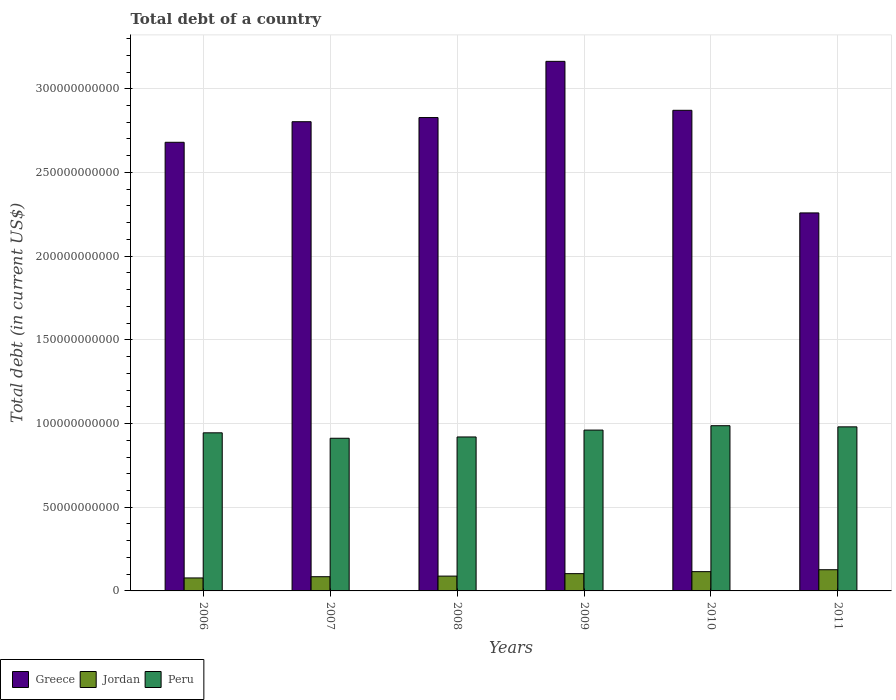How many groups of bars are there?
Your answer should be compact. 6. Are the number of bars per tick equal to the number of legend labels?
Offer a very short reply. Yes. How many bars are there on the 1st tick from the left?
Offer a very short reply. 3. How many bars are there on the 3rd tick from the right?
Make the answer very short. 3. In how many cases, is the number of bars for a given year not equal to the number of legend labels?
Your answer should be very brief. 0. What is the debt in Jordan in 2009?
Give a very brief answer. 1.03e+1. Across all years, what is the maximum debt in Peru?
Your answer should be compact. 9.87e+1. Across all years, what is the minimum debt in Jordan?
Give a very brief answer. 7.75e+09. In which year was the debt in Jordan minimum?
Keep it short and to the point. 2006. What is the total debt in Peru in the graph?
Provide a short and direct response. 5.70e+11. What is the difference between the debt in Greece in 2006 and that in 2009?
Provide a short and direct response. -4.84e+1. What is the difference between the debt in Jordan in 2010 and the debt in Peru in 2006?
Offer a very short reply. -8.29e+1. What is the average debt in Peru per year?
Keep it short and to the point. 9.51e+1. In the year 2007, what is the difference between the debt in Peru and debt in Jordan?
Give a very brief answer. 8.27e+1. In how many years, is the debt in Greece greater than 10000000000 US$?
Give a very brief answer. 6. What is the ratio of the debt in Jordan in 2007 to that in 2009?
Make the answer very short. 0.82. Is the difference between the debt in Peru in 2006 and 2011 greater than the difference between the debt in Jordan in 2006 and 2011?
Offer a very short reply. Yes. What is the difference between the highest and the second highest debt in Jordan?
Keep it short and to the point. 1.15e+09. What is the difference between the highest and the lowest debt in Peru?
Your answer should be very brief. 7.50e+09. What does the 2nd bar from the right in 2006 represents?
Provide a succinct answer. Jordan. How many bars are there?
Your answer should be very brief. 18. Are all the bars in the graph horizontal?
Offer a terse response. No. What is the difference between two consecutive major ticks on the Y-axis?
Your answer should be very brief. 5.00e+1. Are the values on the major ticks of Y-axis written in scientific E-notation?
Offer a terse response. No. Does the graph contain any zero values?
Offer a very short reply. No. Does the graph contain grids?
Give a very brief answer. Yes. How many legend labels are there?
Offer a very short reply. 3. How are the legend labels stacked?
Ensure brevity in your answer.  Horizontal. What is the title of the graph?
Offer a terse response. Total debt of a country. Does "Middle East & North Africa (developing only)" appear as one of the legend labels in the graph?
Your answer should be compact. No. What is the label or title of the Y-axis?
Keep it short and to the point. Total debt (in current US$). What is the Total debt (in current US$) in Greece in 2006?
Provide a succinct answer. 2.68e+11. What is the Total debt (in current US$) in Jordan in 2006?
Offer a terse response. 7.75e+09. What is the Total debt (in current US$) in Peru in 2006?
Ensure brevity in your answer.  9.45e+1. What is the Total debt (in current US$) of Greece in 2007?
Provide a succinct answer. 2.80e+11. What is the Total debt (in current US$) in Jordan in 2007?
Offer a terse response. 8.49e+09. What is the Total debt (in current US$) of Peru in 2007?
Provide a succinct answer. 9.12e+1. What is the Total debt (in current US$) of Greece in 2008?
Provide a short and direct response. 2.83e+11. What is the Total debt (in current US$) of Jordan in 2008?
Make the answer very short. 8.85e+09. What is the Total debt (in current US$) of Peru in 2008?
Ensure brevity in your answer.  9.20e+1. What is the Total debt (in current US$) of Greece in 2009?
Offer a terse response. 3.16e+11. What is the Total debt (in current US$) of Jordan in 2009?
Ensure brevity in your answer.  1.03e+1. What is the Total debt (in current US$) of Peru in 2009?
Your answer should be very brief. 9.61e+1. What is the Total debt (in current US$) of Greece in 2010?
Provide a succinct answer. 2.87e+11. What is the Total debt (in current US$) in Jordan in 2010?
Keep it short and to the point. 1.15e+1. What is the Total debt (in current US$) in Peru in 2010?
Offer a very short reply. 9.87e+1. What is the Total debt (in current US$) in Greece in 2011?
Give a very brief answer. 2.26e+11. What is the Total debt (in current US$) in Jordan in 2011?
Ensure brevity in your answer.  1.27e+1. What is the Total debt (in current US$) in Peru in 2011?
Offer a terse response. 9.80e+1. Across all years, what is the maximum Total debt (in current US$) in Greece?
Keep it short and to the point. 3.16e+11. Across all years, what is the maximum Total debt (in current US$) of Jordan?
Your answer should be very brief. 1.27e+1. Across all years, what is the maximum Total debt (in current US$) in Peru?
Make the answer very short. 9.87e+1. Across all years, what is the minimum Total debt (in current US$) in Greece?
Your answer should be compact. 2.26e+11. Across all years, what is the minimum Total debt (in current US$) of Jordan?
Offer a terse response. 7.75e+09. Across all years, what is the minimum Total debt (in current US$) in Peru?
Give a very brief answer. 9.12e+1. What is the total Total debt (in current US$) of Greece in the graph?
Give a very brief answer. 1.66e+12. What is the total Total debt (in current US$) of Jordan in the graph?
Your answer should be very brief. 5.96e+1. What is the total Total debt (in current US$) of Peru in the graph?
Your answer should be compact. 5.70e+11. What is the difference between the Total debt (in current US$) of Greece in 2006 and that in 2007?
Provide a succinct answer. -1.23e+1. What is the difference between the Total debt (in current US$) in Jordan in 2006 and that in 2007?
Ensure brevity in your answer.  -7.34e+08. What is the difference between the Total debt (in current US$) of Peru in 2006 and that in 2007?
Your answer should be very brief. 3.25e+09. What is the difference between the Total debt (in current US$) in Greece in 2006 and that in 2008?
Offer a terse response. -1.48e+1. What is the difference between the Total debt (in current US$) in Jordan in 2006 and that in 2008?
Make the answer very short. -1.10e+09. What is the difference between the Total debt (in current US$) of Peru in 2006 and that in 2008?
Offer a very short reply. 2.48e+09. What is the difference between the Total debt (in current US$) of Greece in 2006 and that in 2009?
Your answer should be very brief. -4.84e+1. What is the difference between the Total debt (in current US$) in Jordan in 2006 and that in 2009?
Your response must be concise. -2.56e+09. What is the difference between the Total debt (in current US$) in Peru in 2006 and that in 2009?
Give a very brief answer. -1.63e+09. What is the difference between the Total debt (in current US$) of Greece in 2006 and that in 2010?
Your answer should be compact. -1.91e+1. What is the difference between the Total debt (in current US$) of Jordan in 2006 and that in 2010?
Offer a terse response. -3.76e+09. What is the difference between the Total debt (in current US$) of Peru in 2006 and that in 2010?
Make the answer very short. -4.25e+09. What is the difference between the Total debt (in current US$) in Greece in 2006 and that in 2011?
Your response must be concise. 4.22e+1. What is the difference between the Total debt (in current US$) of Jordan in 2006 and that in 2011?
Your answer should be compact. -4.91e+09. What is the difference between the Total debt (in current US$) in Peru in 2006 and that in 2011?
Ensure brevity in your answer.  -3.56e+09. What is the difference between the Total debt (in current US$) of Greece in 2007 and that in 2008?
Keep it short and to the point. -2.48e+09. What is the difference between the Total debt (in current US$) of Jordan in 2007 and that in 2008?
Provide a succinct answer. -3.68e+08. What is the difference between the Total debt (in current US$) of Peru in 2007 and that in 2008?
Offer a very short reply. -7.72e+08. What is the difference between the Total debt (in current US$) of Greece in 2007 and that in 2009?
Your response must be concise. -3.61e+1. What is the difference between the Total debt (in current US$) in Jordan in 2007 and that in 2009?
Your answer should be very brief. -1.83e+09. What is the difference between the Total debt (in current US$) in Peru in 2007 and that in 2009?
Your answer should be compact. -4.88e+09. What is the difference between the Total debt (in current US$) in Greece in 2007 and that in 2010?
Provide a succinct answer. -6.82e+09. What is the difference between the Total debt (in current US$) in Jordan in 2007 and that in 2010?
Your answer should be compact. -3.03e+09. What is the difference between the Total debt (in current US$) in Peru in 2007 and that in 2010?
Your answer should be very brief. -7.50e+09. What is the difference between the Total debt (in current US$) of Greece in 2007 and that in 2011?
Your response must be concise. 5.45e+1. What is the difference between the Total debt (in current US$) in Jordan in 2007 and that in 2011?
Ensure brevity in your answer.  -4.18e+09. What is the difference between the Total debt (in current US$) in Peru in 2007 and that in 2011?
Make the answer very short. -6.81e+09. What is the difference between the Total debt (in current US$) in Greece in 2008 and that in 2009?
Your answer should be compact. -3.36e+1. What is the difference between the Total debt (in current US$) of Jordan in 2008 and that in 2009?
Provide a succinct answer. -1.46e+09. What is the difference between the Total debt (in current US$) of Peru in 2008 and that in 2009?
Your answer should be very brief. -4.11e+09. What is the difference between the Total debt (in current US$) of Greece in 2008 and that in 2010?
Your response must be concise. -4.34e+09. What is the difference between the Total debt (in current US$) in Jordan in 2008 and that in 2010?
Give a very brief answer. -2.66e+09. What is the difference between the Total debt (in current US$) in Peru in 2008 and that in 2010?
Provide a succinct answer. -6.73e+09. What is the difference between the Total debt (in current US$) in Greece in 2008 and that in 2011?
Ensure brevity in your answer.  5.70e+1. What is the difference between the Total debt (in current US$) of Jordan in 2008 and that in 2011?
Your answer should be compact. -3.81e+09. What is the difference between the Total debt (in current US$) of Peru in 2008 and that in 2011?
Give a very brief answer. -6.04e+09. What is the difference between the Total debt (in current US$) in Greece in 2009 and that in 2010?
Keep it short and to the point. 2.92e+1. What is the difference between the Total debt (in current US$) of Jordan in 2009 and that in 2010?
Your answer should be very brief. -1.20e+09. What is the difference between the Total debt (in current US$) of Peru in 2009 and that in 2010?
Your response must be concise. -2.62e+09. What is the difference between the Total debt (in current US$) in Greece in 2009 and that in 2011?
Your response must be concise. 9.05e+1. What is the difference between the Total debt (in current US$) of Jordan in 2009 and that in 2011?
Offer a terse response. -2.35e+09. What is the difference between the Total debt (in current US$) in Peru in 2009 and that in 2011?
Your answer should be compact. -1.93e+09. What is the difference between the Total debt (in current US$) of Greece in 2010 and that in 2011?
Offer a very short reply. 6.13e+1. What is the difference between the Total debt (in current US$) in Jordan in 2010 and that in 2011?
Provide a succinct answer. -1.15e+09. What is the difference between the Total debt (in current US$) in Peru in 2010 and that in 2011?
Make the answer very short. 6.85e+08. What is the difference between the Total debt (in current US$) in Greece in 2006 and the Total debt (in current US$) in Jordan in 2007?
Your answer should be very brief. 2.60e+11. What is the difference between the Total debt (in current US$) of Greece in 2006 and the Total debt (in current US$) of Peru in 2007?
Your answer should be very brief. 1.77e+11. What is the difference between the Total debt (in current US$) of Jordan in 2006 and the Total debt (in current US$) of Peru in 2007?
Make the answer very short. -8.35e+1. What is the difference between the Total debt (in current US$) in Greece in 2006 and the Total debt (in current US$) in Jordan in 2008?
Keep it short and to the point. 2.59e+11. What is the difference between the Total debt (in current US$) of Greece in 2006 and the Total debt (in current US$) of Peru in 2008?
Your answer should be compact. 1.76e+11. What is the difference between the Total debt (in current US$) in Jordan in 2006 and the Total debt (in current US$) in Peru in 2008?
Provide a succinct answer. -8.42e+1. What is the difference between the Total debt (in current US$) in Greece in 2006 and the Total debt (in current US$) in Jordan in 2009?
Provide a short and direct response. 2.58e+11. What is the difference between the Total debt (in current US$) of Greece in 2006 and the Total debt (in current US$) of Peru in 2009?
Provide a short and direct response. 1.72e+11. What is the difference between the Total debt (in current US$) in Jordan in 2006 and the Total debt (in current US$) in Peru in 2009?
Offer a terse response. -8.83e+1. What is the difference between the Total debt (in current US$) of Greece in 2006 and the Total debt (in current US$) of Jordan in 2010?
Offer a very short reply. 2.57e+11. What is the difference between the Total debt (in current US$) in Greece in 2006 and the Total debt (in current US$) in Peru in 2010?
Your response must be concise. 1.69e+11. What is the difference between the Total debt (in current US$) of Jordan in 2006 and the Total debt (in current US$) of Peru in 2010?
Your answer should be compact. -9.09e+1. What is the difference between the Total debt (in current US$) in Greece in 2006 and the Total debt (in current US$) in Jordan in 2011?
Your response must be concise. 2.55e+11. What is the difference between the Total debt (in current US$) of Greece in 2006 and the Total debt (in current US$) of Peru in 2011?
Keep it short and to the point. 1.70e+11. What is the difference between the Total debt (in current US$) in Jordan in 2006 and the Total debt (in current US$) in Peru in 2011?
Your answer should be compact. -9.03e+1. What is the difference between the Total debt (in current US$) of Greece in 2007 and the Total debt (in current US$) of Jordan in 2008?
Your response must be concise. 2.71e+11. What is the difference between the Total debt (in current US$) in Greece in 2007 and the Total debt (in current US$) in Peru in 2008?
Provide a succinct answer. 1.88e+11. What is the difference between the Total debt (in current US$) of Jordan in 2007 and the Total debt (in current US$) of Peru in 2008?
Your answer should be very brief. -8.35e+1. What is the difference between the Total debt (in current US$) of Greece in 2007 and the Total debt (in current US$) of Jordan in 2009?
Keep it short and to the point. 2.70e+11. What is the difference between the Total debt (in current US$) in Greece in 2007 and the Total debt (in current US$) in Peru in 2009?
Ensure brevity in your answer.  1.84e+11. What is the difference between the Total debt (in current US$) in Jordan in 2007 and the Total debt (in current US$) in Peru in 2009?
Offer a very short reply. -8.76e+1. What is the difference between the Total debt (in current US$) of Greece in 2007 and the Total debt (in current US$) of Jordan in 2010?
Give a very brief answer. 2.69e+11. What is the difference between the Total debt (in current US$) of Greece in 2007 and the Total debt (in current US$) of Peru in 2010?
Offer a very short reply. 1.82e+11. What is the difference between the Total debt (in current US$) of Jordan in 2007 and the Total debt (in current US$) of Peru in 2010?
Keep it short and to the point. -9.02e+1. What is the difference between the Total debt (in current US$) in Greece in 2007 and the Total debt (in current US$) in Jordan in 2011?
Provide a succinct answer. 2.68e+11. What is the difference between the Total debt (in current US$) of Greece in 2007 and the Total debt (in current US$) of Peru in 2011?
Give a very brief answer. 1.82e+11. What is the difference between the Total debt (in current US$) in Jordan in 2007 and the Total debt (in current US$) in Peru in 2011?
Your answer should be very brief. -8.95e+1. What is the difference between the Total debt (in current US$) in Greece in 2008 and the Total debt (in current US$) in Jordan in 2009?
Provide a succinct answer. 2.72e+11. What is the difference between the Total debt (in current US$) in Greece in 2008 and the Total debt (in current US$) in Peru in 2009?
Keep it short and to the point. 1.87e+11. What is the difference between the Total debt (in current US$) of Jordan in 2008 and the Total debt (in current US$) of Peru in 2009?
Your answer should be compact. -8.72e+1. What is the difference between the Total debt (in current US$) of Greece in 2008 and the Total debt (in current US$) of Jordan in 2010?
Provide a short and direct response. 2.71e+11. What is the difference between the Total debt (in current US$) in Greece in 2008 and the Total debt (in current US$) in Peru in 2010?
Provide a succinct answer. 1.84e+11. What is the difference between the Total debt (in current US$) in Jordan in 2008 and the Total debt (in current US$) in Peru in 2010?
Ensure brevity in your answer.  -8.98e+1. What is the difference between the Total debt (in current US$) in Greece in 2008 and the Total debt (in current US$) in Jordan in 2011?
Offer a terse response. 2.70e+11. What is the difference between the Total debt (in current US$) of Greece in 2008 and the Total debt (in current US$) of Peru in 2011?
Your answer should be very brief. 1.85e+11. What is the difference between the Total debt (in current US$) in Jordan in 2008 and the Total debt (in current US$) in Peru in 2011?
Offer a very short reply. -8.92e+1. What is the difference between the Total debt (in current US$) of Greece in 2009 and the Total debt (in current US$) of Jordan in 2010?
Your response must be concise. 3.05e+11. What is the difference between the Total debt (in current US$) of Greece in 2009 and the Total debt (in current US$) of Peru in 2010?
Ensure brevity in your answer.  2.18e+11. What is the difference between the Total debt (in current US$) in Jordan in 2009 and the Total debt (in current US$) in Peru in 2010?
Make the answer very short. -8.84e+1. What is the difference between the Total debt (in current US$) of Greece in 2009 and the Total debt (in current US$) of Jordan in 2011?
Offer a terse response. 3.04e+11. What is the difference between the Total debt (in current US$) in Greece in 2009 and the Total debt (in current US$) in Peru in 2011?
Your answer should be very brief. 2.18e+11. What is the difference between the Total debt (in current US$) in Jordan in 2009 and the Total debt (in current US$) in Peru in 2011?
Provide a short and direct response. -8.77e+1. What is the difference between the Total debt (in current US$) in Greece in 2010 and the Total debt (in current US$) in Jordan in 2011?
Provide a short and direct response. 2.74e+11. What is the difference between the Total debt (in current US$) of Greece in 2010 and the Total debt (in current US$) of Peru in 2011?
Keep it short and to the point. 1.89e+11. What is the difference between the Total debt (in current US$) in Jordan in 2010 and the Total debt (in current US$) in Peru in 2011?
Your response must be concise. -8.65e+1. What is the average Total debt (in current US$) of Greece per year?
Offer a very short reply. 2.77e+11. What is the average Total debt (in current US$) in Jordan per year?
Keep it short and to the point. 9.93e+09. What is the average Total debt (in current US$) of Peru per year?
Provide a succinct answer. 9.51e+1. In the year 2006, what is the difference between the Total debt (in current US$) in Greece and Total debt (in current US$) in Jordan?
Give a very brief answer. 2.60e+11. In the year 2006, what is the difference between the Total debt (in current US$) in Greece and Total debt (in current US$) in Peru?
Your response must be concise. 1.74e+11. In the year 2006, what is the difference between the Total debt (in current US$) of Jordan and Total debt (in current US$) of Peru?
Provide a succinct answer. -8.67e+1. In the year 2007, what is the difference between the Total debt (in current US$) of Greece and Total debt (in current US$) of Jordan?
Give a very brief answer. 2.72e+11. In the year 2007, what is the difference between the Total debt (in current US$) of Greece and Total debt (in current US$) of Peru?
Ensure brevity in your answer.  1.89e+11. In the year 2007, what is the difference between the Total debt (in current US$) of Jordan and Total debt (in current US$) of Peru?
Offer a terse response. -8.27e+1. In the year 2008, what is the difference between the Total debt (in current US$) of Greece and Total debt (in current US$) of Jordan?
Make the answer very short. 2.74e+11. In the year 2008, what is the difference between the Total debt (in current US$) in Greece and Total debt (in current US$) in Peru?
Provide a succinct answer. 1.91e+11. In the year 2008, what is the difference between the Total debt (in current US$) in Jordan and Total debt (in current US$) in Peru?
Give a very brief answer. -8.31e+1. In the year 2009, what is the difference between the Total debt (in current US$) in Greece and Total debt (in current US$) in Jordan?
Provide a short and direct response. 3.06e+11. In the year 2009, what is the difference between the Total debt (in current US$) in Greece and Total debt (in current US$) in Peru?
Offer a terse response. 2.20e+11. In the year 2009, what is the difference between the Total debt (in current US$) in Jordan and Total debt (in current US$) in Peru?
Offer a terse response. -8.58e+1. In the year 2010, what is the difference between the Total debt (in current US$) of Greece and Total debt (in current US$) of Jordan?
Your response must be concise. 2.76e+11. In the year 2010, what is the difference between the Total debt (in current US$) of Greece and Total debt (in current US$) of Peru?
Ensure brevity in your answer.  1.88e+11. In the year 2010, what is the difference between the Total debt (in current US$) of Jordan and Total debt (in current US$) of Peru?
Offer a very short reply. -8.72e+1. In the year 2011, what is the difference between the Total debt (in current US$) of Greece and Total debt (in current US$) of Jordan?
Give a very brief answer. 2.13e+11. In the year 2011, what is the difference between the Total debt (in current US$) in Greece and Total debt (in current US$) in Peru?
Keep it short and to the point. 1.28e+11. In the year 2011, what is the difference between the Total debt (in current US$) in Jordan and Total debt (in current US$) in Peru?
Make the answer very short. -8.54e+1. What is the ratio of the Total debt (in current US$) of Greece in 2006 to that in 2007?
Your response must be concise. 0.96. What is the ratio of the Total debt (in current US$) in Jordan in 2006 to that in 2007?
Keep it short and to the point. 0.91. What is the ratio of the Total debt (in current US$) in Peru in 2006 to that in 2007?
Ensure brevity in your answer.  1.04. What is the ratio of the Total debt (in current US$) in Greece in 2006 to that in 2008?
Make the answer very short. 0.95. What is the ratio of the Total debt (in current US$) in Jordan in 2006 to that in 2008?
Provide a succinct answer. 0.88. What is the ratio of the Total debt (in current US$) of Peru in 2006 to that in 2008?
Your answer should be very brief. 1.03. What is the ratio of the Total debt (in current US$) of Greece in 2006 to that in 2009?
Offer a terse response. 0.85. What is the ratio of the Total debt (in current US$) in Jordan in 2006 to that in 2009?
Provide a short and direct response. 0.75. What is the ratio of the Total debt (in current US$) of Greece in 2006 to that in 2010?
Keep it short and to the point. 0.93. What is the ratio of the Total debt (in current US$) in Jordan in 2006 to that in 2010?
Provide a succinct answer. 0.67. What is the ratio of the Total debt (in current US$) in Peru in 2006 to that in 2010?
Provide a short and direct response. 0.96. What is the ratio of the Total debt (in current US$) in Greece in 2006 to that in 2011?
Provide a succinct answer. 1.19. What is the ratio of the Total debt (in current US$) in Jordan in 2006 to that in 2011?
Provide a succinct answer. 0.61. What is the ratio of the Total debt (in current US$) of Peru in 2006 to that in 2011?
Offer a very short reply. 0.96. What is the ratio of the Total debt (in current US$) in Jordan in 2007 to that in 2008?
Keep it short and to the point. 0.96. What is the ratio of the Total debt (in current US$) of Peru in 2007 to that in 2008?
Give a very brief answer. 0.99. What is the ratio of the Total debt (in current US$) of Greece in 2007 to that in 2009?
Provide a short and direct response. 0.89. What is the ratio of the Total debt (in current US$) of Jordan in 2007 to that in 2009?
Provide a short and direct response. 0.82. What is the ratio of the Total debt (in current US$) of Peru in 2007 to that in 2009?
Your response must be concise. 0.95. What is the ratio of the Total debt (in current US$) in Greece in 2007 to that in 2010?
Your answer should be compact. 0.98. What is the ratio of the Total debt (in current US$) in Jordan in 2007 to that in 2010?
Keep it short and to the point. 0.74. What is the ratio of the Total debt (in current US$) of Peru in 2007 to that in 2010?
Your answer should be very brief. 0.92. What is the ratio of the Total debt (in current US$) in Greece in 2007 to that in 2011?
Your answer should be compact. 1.24. What is the ratio of the Total debt (in current US$) in Jordan in 2007 to that in 2011?
Your response must be concise. 0.67. What is the ratio of the Total debt (in current US$) of Peru in 2007 to that in 2011?
Make the answer very short. 0.93. What is the ratio of the Total debt (in current US$) of Greece in 2008 to that in 2009?
Provide a succinct answer. 0.89. What is the ratio of the Total debt (in current US$) in Jordan in 2008 to that in 2009?
Offer a very short reply. 0.86. What is the ratio of the Total debt (in current US$) of Peru in 2008 to that in 2009?
Your answer should be compact. 0.96. What is the ratio of the Total debt (in current US$) in Greece in 2008 to that in 2010?
Provide a succinct answer. 0.98. What is the ratio of the Total debt (in current US$) in Jordan in 2008 to that in 2010?
Provide a short and direct response. 0.77. What is the ratio of the Total debt (in current US$) in Peru in 2008 to that in 2010?
Your answer should be compact. 0.93. What is the ratio of the Total debt (in current US$) of Greece in 2008 to that in 2011?
Make the answer very short. 1.25. What is the ratio of the Total debt (in current US$) in Jordan in 2008 to that in 2011?
Provide a succinct answer. 0.7. What is the ratio of the Total debt (in current US$) in Peru in 2008 to that in 2011?
Provide a short and direct response. 0.94. What is the ratio of the Total debt (in current US$) in Greece in 2009 to that in 2010?
Your response must be concise. 1.1. What is the ratio of the Total debt (in current US$) of Jordan in 2009 to that in 2010?
Give a very brief answer. 0.9. What is the ratio of the Total debt (in current US$) in Peru in 2009 to that in 2010?
Provide a short and direct response. 0.97. What is the ratio of the Total debt (in current US$) in Greece in 2009 to that in 2011?
Your response must be concise. 1.4. What is the ratio of the Total debt (in current US$) of Jordan in 2009 to that in 2011?
Keep it short and to the point. 0.81. What is the ratio of the Total debt (in current US$) in Peru in 2009 to that in 2011?
Make the answer very short. 0.98. What is the ratio of the Total debt (in current US$) of Greece in 2010 to that in 2011?
Your answer should be very brief. 1.27. What is the ratio of the Total debt (in current US$) in Jordan in 2010 to that in 2011?
Your response must be concise. 0.91. What is the ratio of the Total debt (in current US$) of Peru in 2010 to that in 2011?
Offer a terse response. 1.01. What is the difference between the highest and the second highest Total debt (in current US$) of Greece?
Give a very brief answer. 2.92e+1. What is the difference between the highest and the second highest Total debt (in current US$) in Jordan?
Keep it short and to the point. 1.15e+09. What is the difference between the highest and the second highest Total debt (in current US$) of Peru?
Keep it short and to the point. 6.85e+08. What is the difference between the highest and the lowest Total debt (in current US$) in Greece?
Your answer should be very brief. 9.05e+1. What is the difference between the highest and the lowest Total debt (in current US$) of Jordan?
Make the answer very short. 4.91e+09. What is the difference between the highest and the lowest Total debt (in current US$) of Peru?
Ensure brevity in your answer.  7.50e+09. 